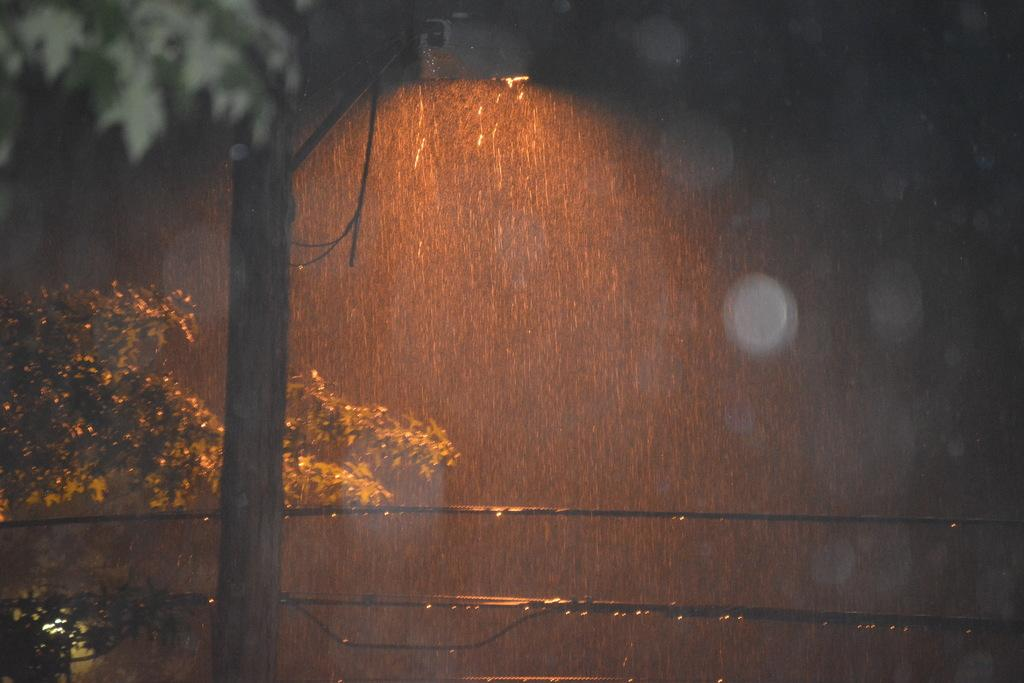What type of vegetation can be seen in the image? There are trees in the image. What else is present in the image besides trees? There are wires in the image. What is the weather like in the image? It is raining in the image. What type of lipstick is the tree wearing in the image? There is no lipstick or tree wearing lipstick present in the image. 